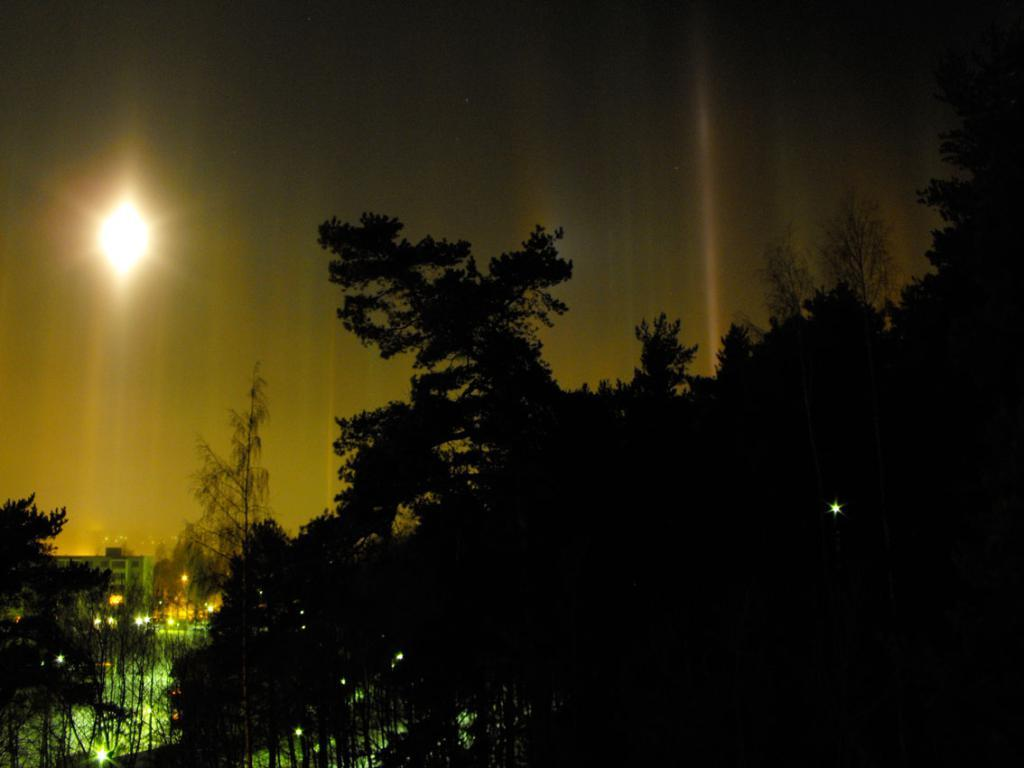What type of vegetation can be seen in the right corner of the image? There are trees in the right corner of the image. What type of structure is located in the left corner of the image? There is a building in the left corner of the image. What can be seen near the building in the left corner of the image? There are lights in the left corner of the image. Can you tell me the taste of the fireman playing chess in the image? There is no fireman or chess game present in the image. What type of creature is shown interacting with the trees on the right side of the image? There is no creature shown interacting with the trees on the right side of the image; only the trees are present. 